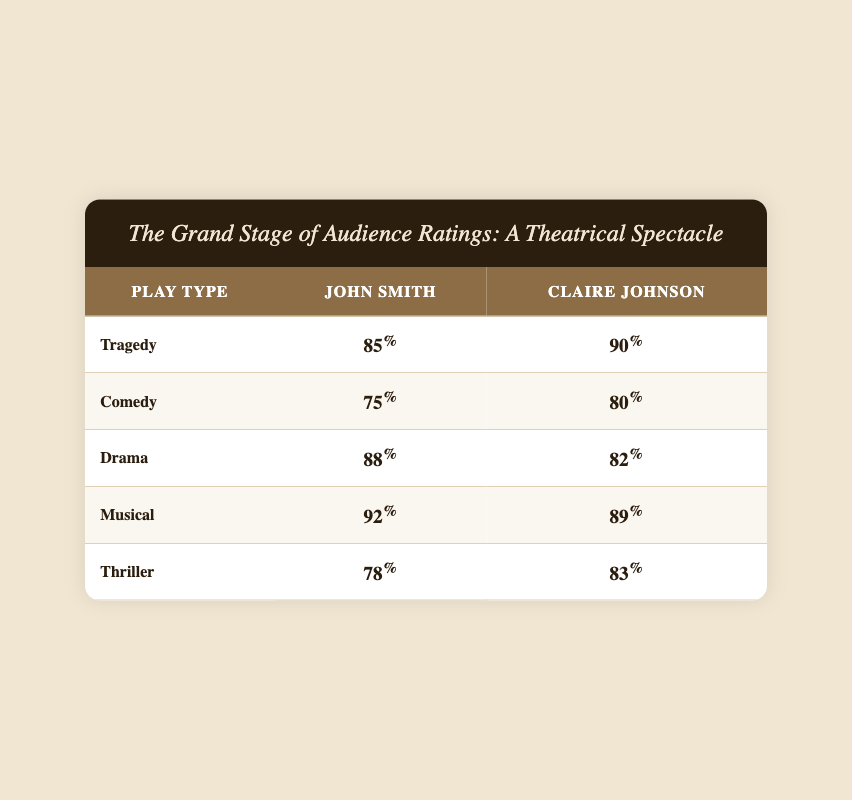What is the audience rating for Tragedy given by Claire Johnson? From the table, in the row corresponding to the Tragedy play type under Claire Johnson's column, the audience rating is 90.
Answer: 90 What is the audience rating for Comedy given by John Smith? In the table, the Comedy row under John Smith's column shows an audience rating of 75.
Answer: 75 Which critic gave a higher rating for Musical? Comparing the ratings for the Musical row, John Smith's rating is 92, while Claire Johnson's rating is 89. Thus, John Smith has the higher rating.
Answer: John Smith What is the average audience rating for all plays given by Claire Johnson? Adding the audience ratings for Claire Johnson: 90 (Tragedy) + 80 (Comedy) + 82 (Drama) + 89 (Musical) + 83 (Thriller) = 424. With 5 plays, the average is 424/5 = 84.8.
Answer: 84.8 Is it true that John Smith rated Thrillers lower than Claire Johnson? Looking at the Thriller row, John Smith rated it 78, while Claire Johnson's rating is 83. Since 78 is less than 83, the statement is true.
Answer: Yes How much higher is the average rating for all plays given by John Smith compared to Claire Johnson? First, calculate John's average: (85 + 75 + 88 + 92 + 78) = 418, then average is 418/5 = 83.6. Now calculate Claire's average: (90 + 80 + 82 + 89 + 83) = 424, her average is 424/5 = 84.8. Then, subtract John's average from Claire's: 84.8 - 83.6 = 1.2.
Answer: 1.2 Which play type received the highest rating from John Smith? Reviewing the ratings for John Smith: 85 (Tragedy), 75 (Comedy), 88 (Drama), 92 (Musical), and 78 (Thriller), the highest is 92 for the Musical.
Answer: Musical Did Claire Johnson give the same rating for both Drama and Comedy? Checking the ratings, Claire rated Drama 82 and Comedy 80. Since these values are different, the answer to this question is no.
Answer: No What is the total audience rating from both critics for the Thriller play type? Looking at the Thriller row, John Smith rated it 78 and Claire Johnson rated it 83. Adding these together gives 78 + 83 = 161.
Answer: 161 